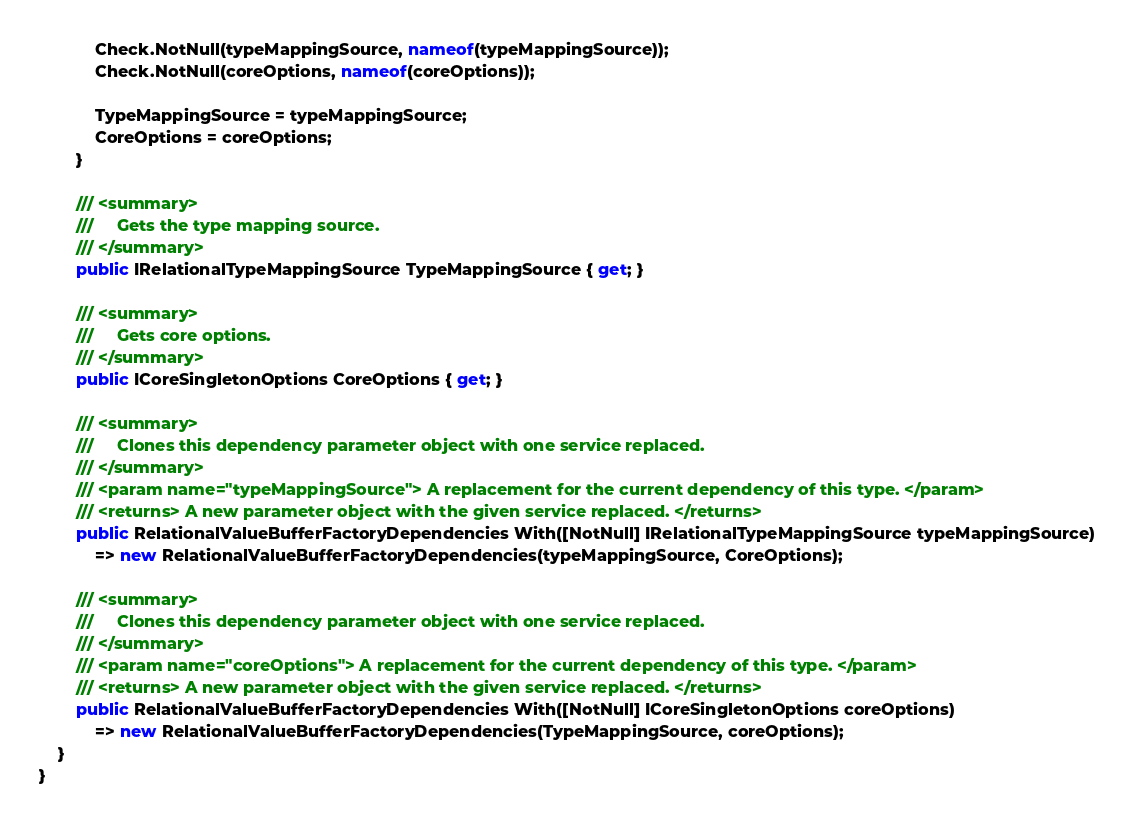<code> <loc_0><loc_0><loc_500><loc_500><_C#_>            Check.NotNull(typeMappingSource, nameof(typeMappingSource));
            Check.NotNull(coreOptions, nameof(coreOptions));

            TypeMappingSource = typeMappingSource;
            CoreOptions = coreOptions;
        }

        /// <summary>
        ///     Gets the type mapping source.
        /// </summary>
        public IRelationalTypeMappingSource TypeMappingSource { get; }

        /// <summary>
        ///     Gets core options.
        /// </summary>
        public ICoreSingletonOptions CoreOptions { get; }

        /// <summary>
        ///     Clones this dependency parameter object with one service replaced.
        /// </summary>
        /// <param name="typeMappingSource"> A replacement for the current dependency of this type. </param>
        /// <returns> A new parameter object with the given service replaced. </returns>
        public RelationalValueBufferFactoryDependencies With([NotNull] IRelationalTypeMappingSource typeMappingSource)
            => new RelationalValueBufferFactoryDependencies(typeMappingSource, CoreOptions);

        /// <summary>
        ///     Clones this dependency parameter object with one service replaced.
        /// </summary>
        /// <param name="coreOptions"> A replacement for the current dependency of this type. </param>
        /// <returns> A new parameter object with the given service replaced. </returns>
        public RelationalValueBufferFactoryDependencies With([NotNull] ICoreSingletonOptions coreOptions)
            => new RelationalValueBufferFactoryDependencies(TypeMappingSource, coreOptions);
    }
}
</code> 